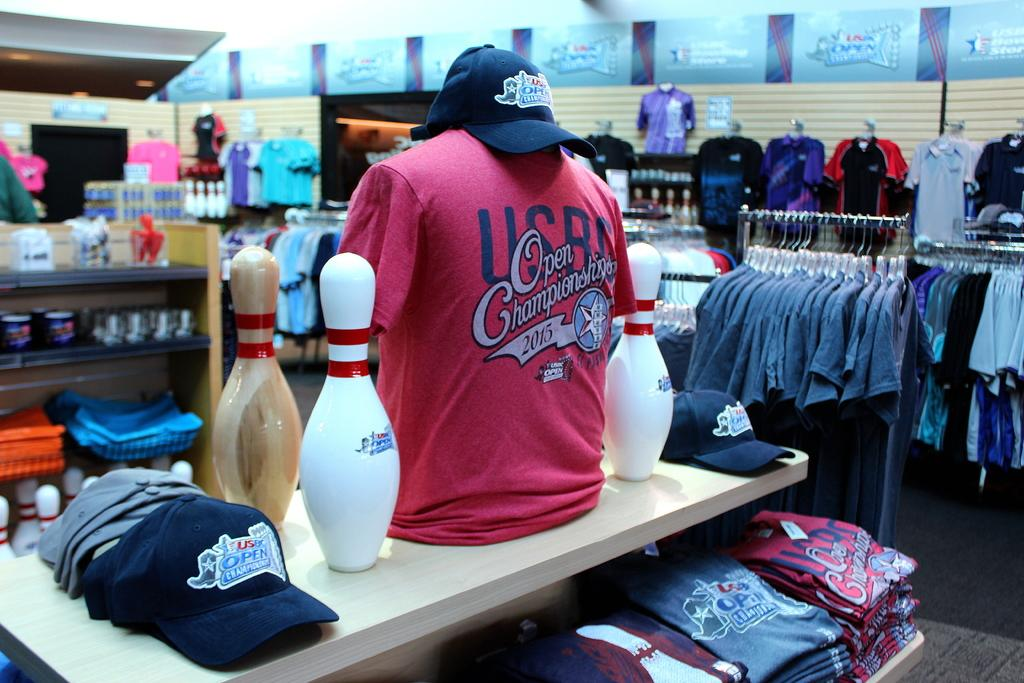<image>
Offer a succinct explanation of the picture presented. A clothing display with a shirt that says Open Championship 2015. 